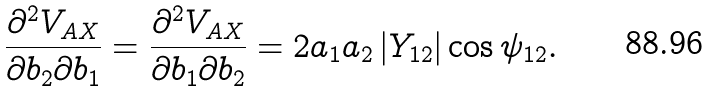<formula> <loc_0><loc_0><loc_500><loc_500>\frac { \partial ^ { 2 } V _ { A X } } { \partial b _ { 2 } \partial b _ { 1 } } = \frac { \partial ^ { 2 } V _ { A X } } { \partial b _ { 1 } \partial b _ { 2 } } = 2 a _ { 1 } a _ { 2 } \left | Y _ { 1 2 } \right | \cos \psi _ { 1 2 } .</formula> 